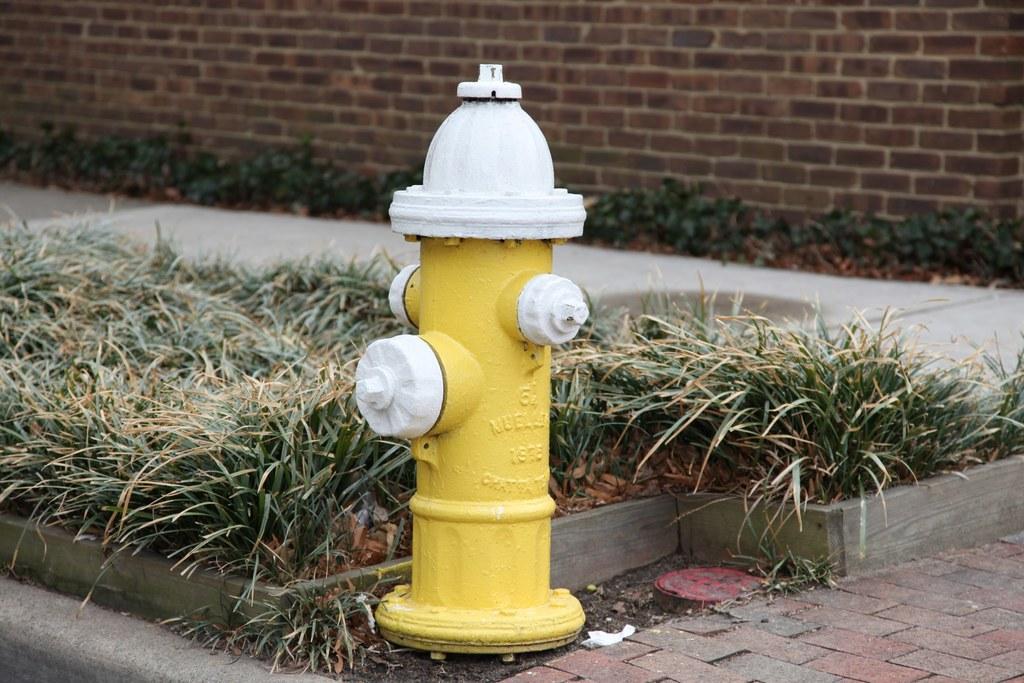Could you give a brief overview of what you see in this image? In this image I can see a fire-hydrant in yellow and white color. I can see the green grass and brick wall. 